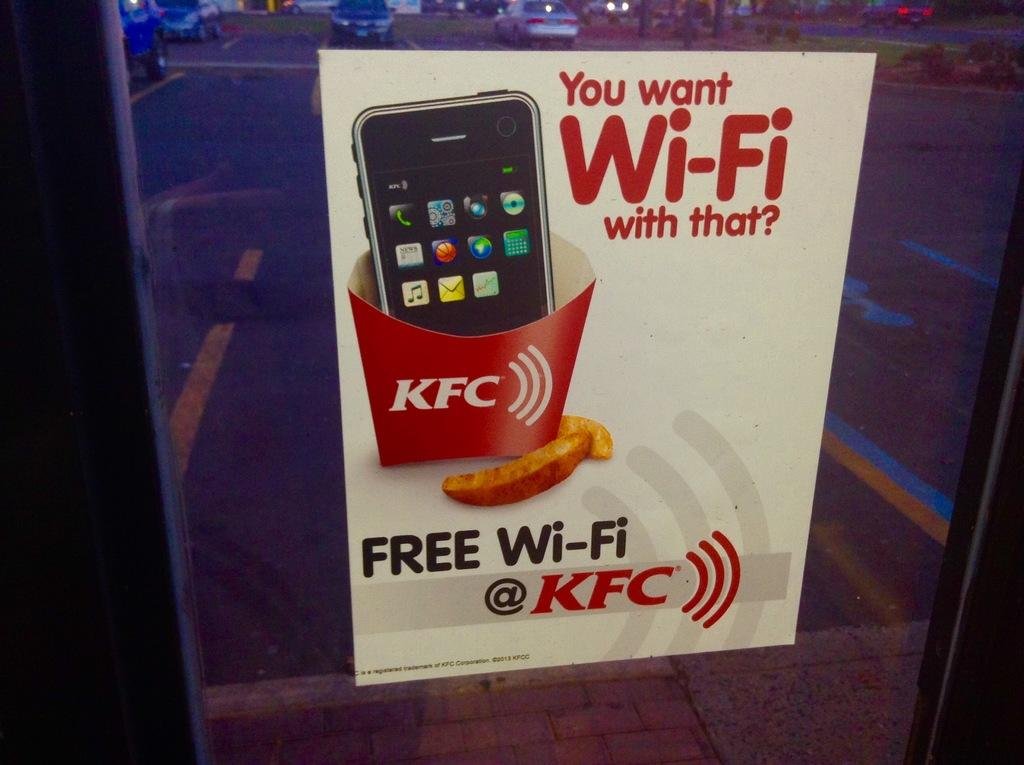<image>
Offer a succinct explanation of the picture presented. A sign for free wi-fi is sponsored by KFC. 